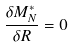Convert formula to latex. <formula><loc_0><loc_0><loc_500><loc_500>\frac { \delta M _ { N } ^ { * } } { \delta R } = 0</formula> 